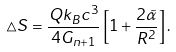Convert formula to latex. <formula><loc_0><loc_0><loc_500><loc_500>\triangle S = \frac { Q k _ { B } c ^ { 3 } } { 4 G _ { n + 1 } } \left [ 1 + \frac { 2 \tilde { \alpha } } { R ^ { 2 } } \right ] .</formula> 